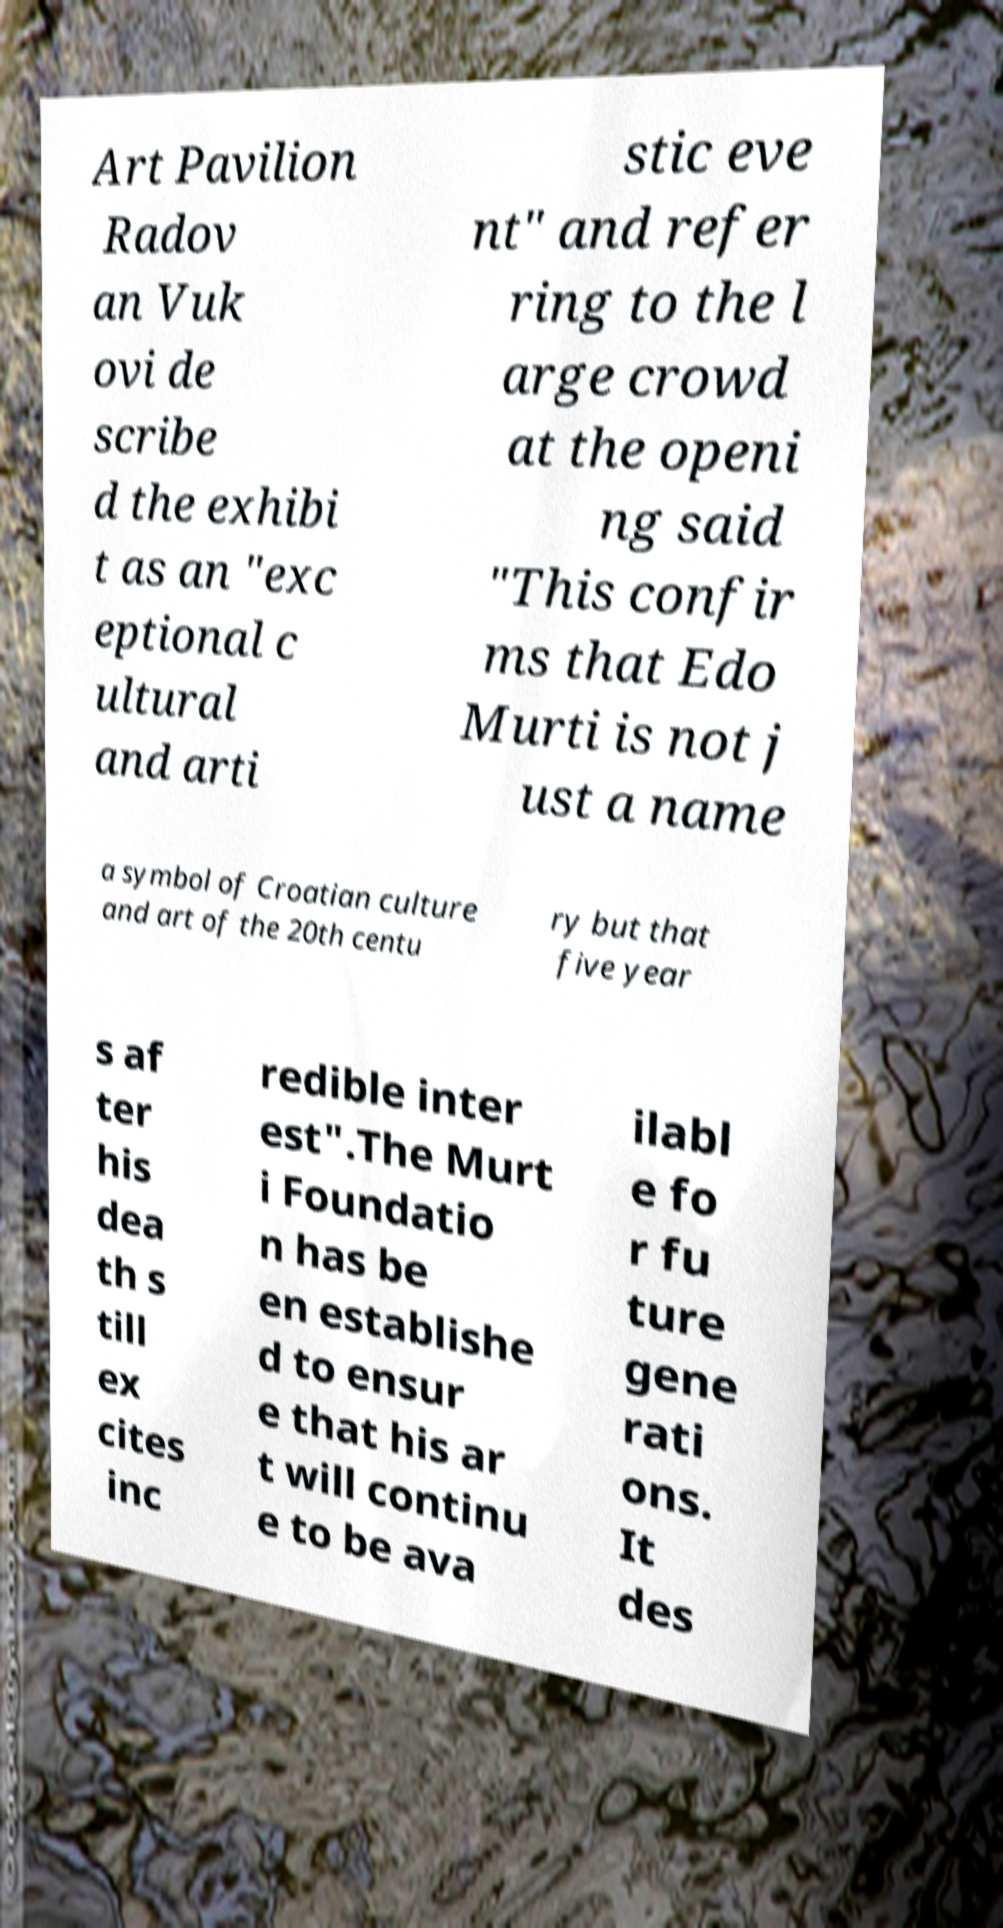There's text embedded in this image that I need extracted. Can you transcribe it verbatim? Art Pavilion Radov an Vuk ovi de scribe d the exhibi t as an "exc eptional c ultural and arti stic eve nt" and refer ring to the l arge crowd at the openi ng said "This confir ms that Edo Murti is not j ust a name a symbol of Croatian culture and art of the 20th centu ry but that five year s af ter his dea th s till ex cites inc redible inter est".The Murt i Foundatio n has be en establishe d to ensur e that his ar t will continu e to be ava ilabl e fo r fu ture gene rati ons. It des 